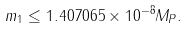<formula> <loc_0><loc_0><loc_500><loc_500>m _ { 1 } \leq 1 . 4 0 7 0 6 5 \times 1 0 ^ { - 8 } M _ { P } .</formula> 